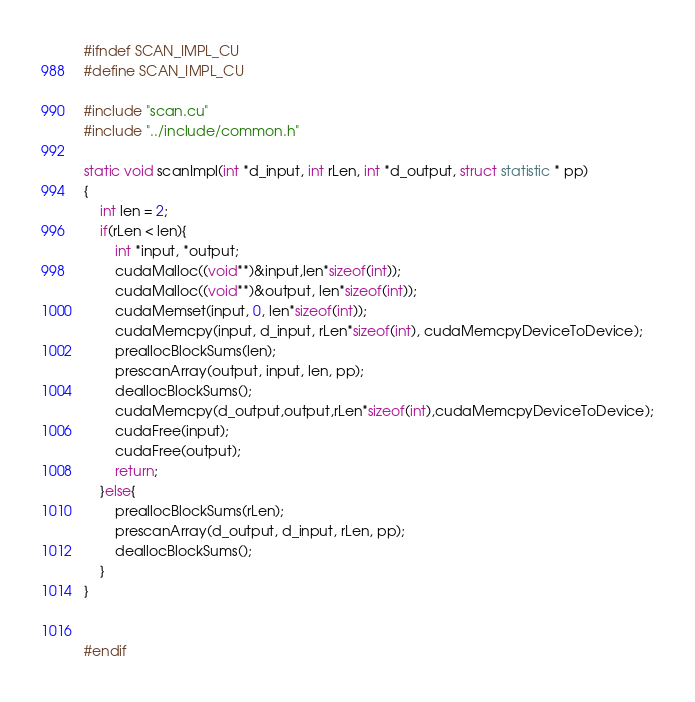<code> <loc_0><loc_0><loc_500><loc_500><_Cuda_>#ifndef SCAN_IMPL_CU
#define SCAN_IMPL_CU

#include "scan.cu"
#include "../include/common.h"

static void scanImpl(int *d_input, int rLen, int *d_output, struct statistic * pp)
{
	int len = 2;
	if(rLen < len){
		int *input, *output;
		cudaMalloc((void**)&input,len*sizeof(int));
		cudaMalloc((void**)&output, len*sizeof(int));
		cudaMemset(input, 0, len*sizeof(int));
		cudaMemcpy(input, d_input, rLen*sizeof(int), cudaMemcpyDeviceToDevice);
		preallocBlockSums(len);
		prescanArray(output, input, len, pp);
		deallocBlockSums();
		cudaMemcpy(d_output,output,rLen*sizeof(int),cudaMemcpyDeviceToDevice);
		cudaFree(input);
		cudaFree(output);
		return;
	}else{
		preallocBlockSums(rLen);
		prescanArray(d_output, d_input, rLen, pp);
		deallocBlockSums();
	}
}


#endif

</code> 